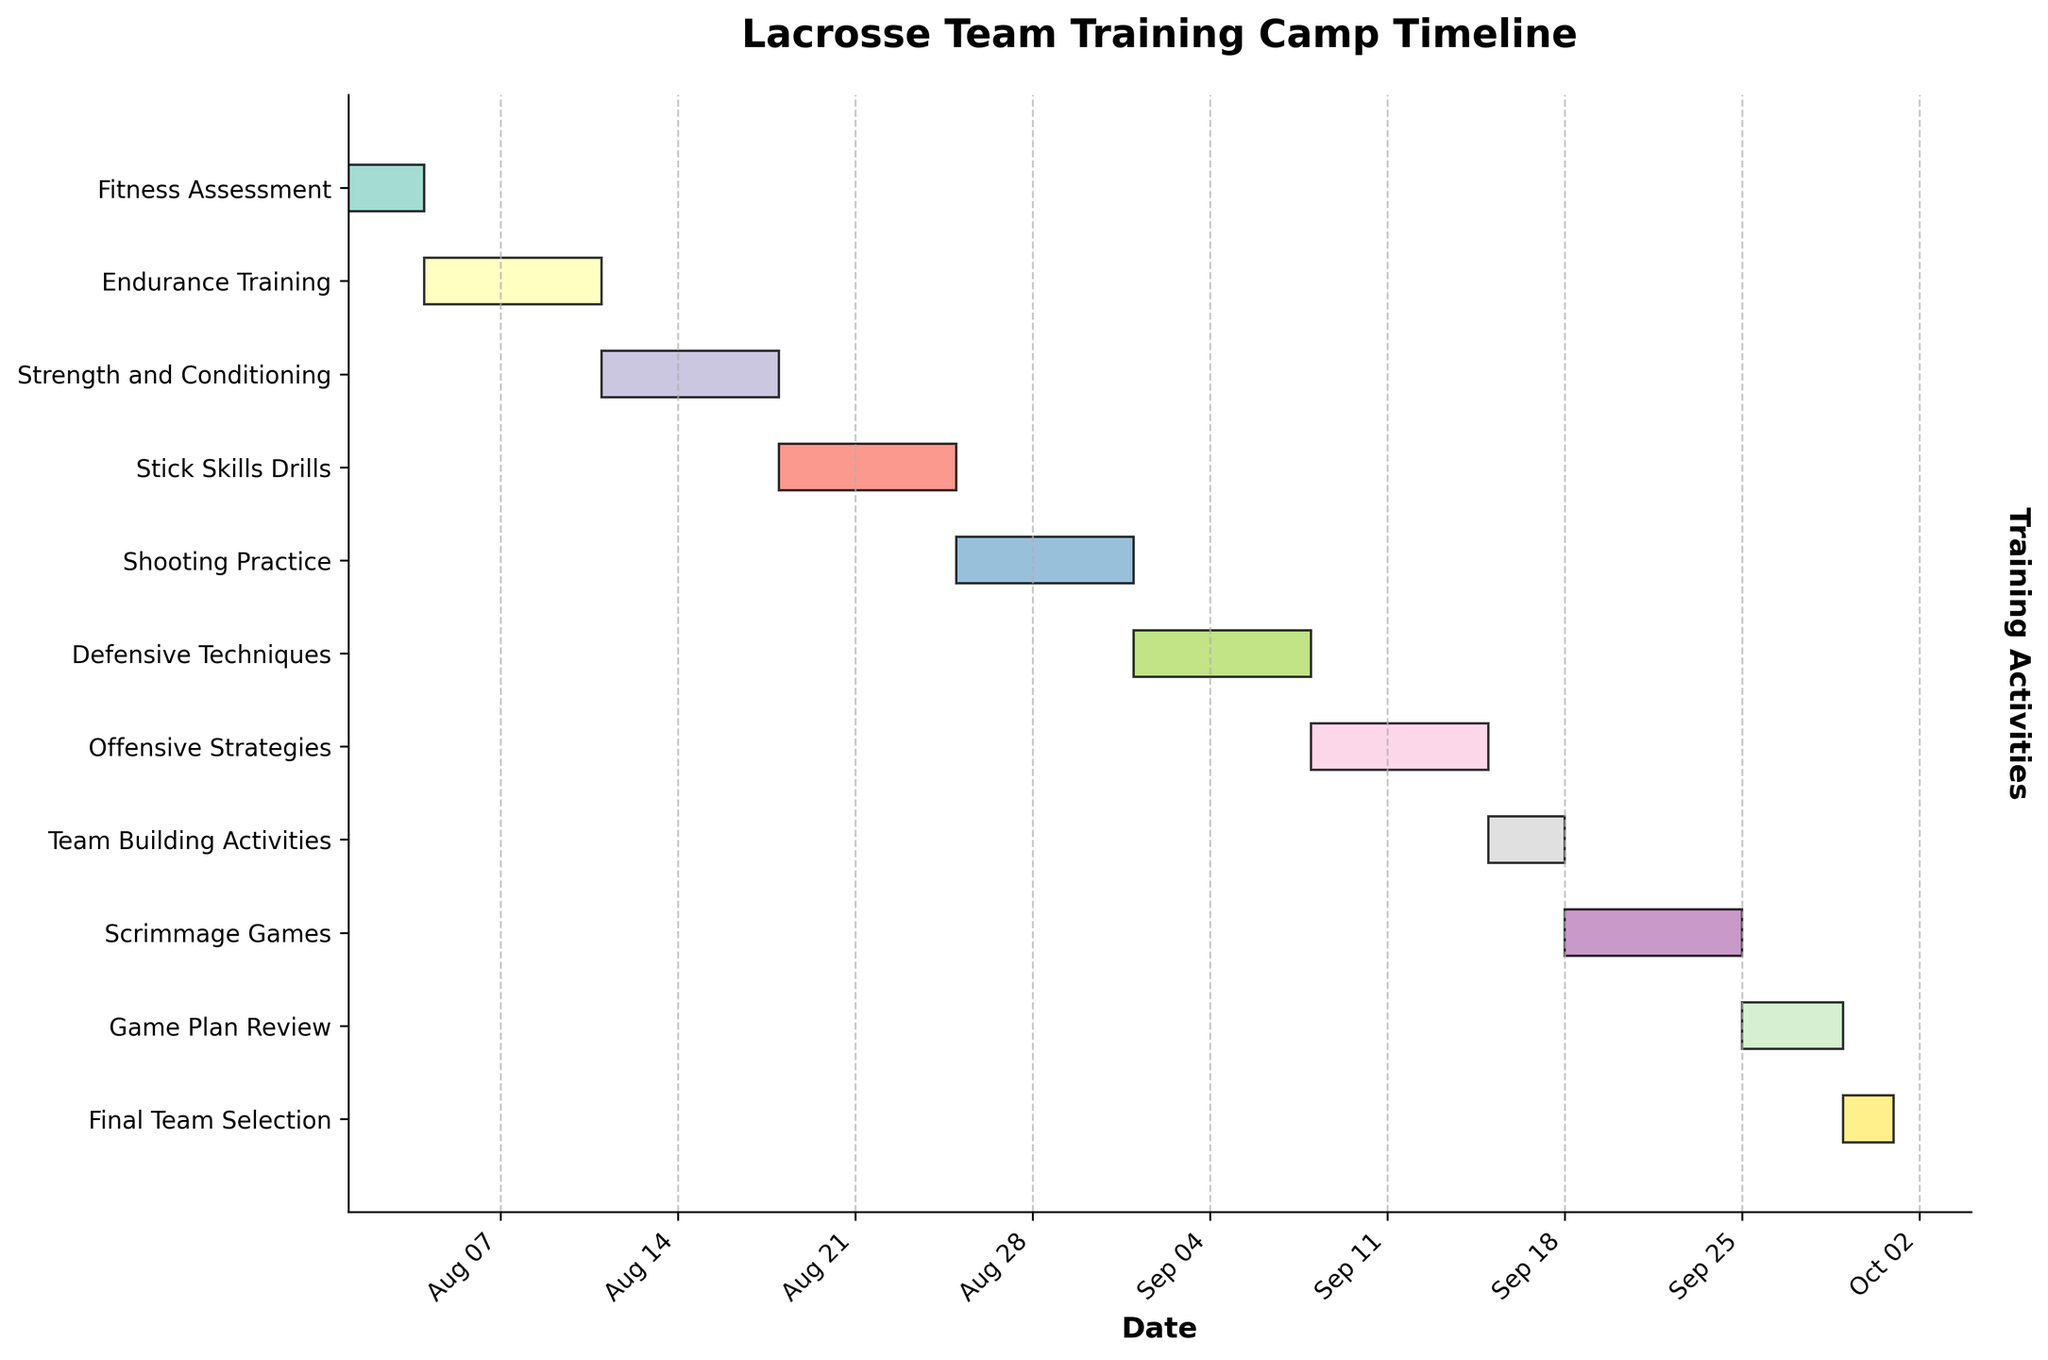What is the duration of the Fitness Assessment task? The Fitness Assessment task starts on August 1, 2023, and ends on August 3, 2023. The task duration is calculated as the difference between the start and end dates plus one day: (August 3 - August 1) + 1 = 3 days.
Answer: 3 days Which task has the longest duration and how long is it? By visually comparing the durations of all the tasks in the Gantt Chart, the Scrimmage Games task has the longest bar. The Scrimmage Games task starts on September 18, 2023, and ends on September 24, 2023. Therefore, its duration is (September 24 - September 18) + 1 = 7 days.
Answer: Scrimmage Games, 7 days What is the total duration of all training activities combined? Calculating the total duration involves summing up individual task durations: 3 (Fitness Assessment) + 7 (Endurance Training) + 7 (Strength and Conditioning) + 7 (Stick Skills Drills) + 7 (Shooting Practice) + 7 (Defensive Techniques) + 7 (Offensive Strategies) + 3 (Team Building Activities) + 7 (Scrimmage Games) + 4 (Game Plan Review) + 2 (Final Team Selection) = 61 days.
Answer: 61 days Which tasks overlap or happen sequentially without any gaps? Visually checking the timeline, the tasks Endurance Training, Strength and Conditioning, Stick Skills Drills, Shooting Practice, Defensive Techniques, and Offensive Strategies are sequential, each following the previous one without gaps. Additionally, the tasks Scrimmage Games and Game Plan Review are sequential.
Answer: Endurance Training to Offensive Strategies, Scrimmage Games to Game Plan Review How does the duration of Team Building Activities compare to Shooting Practice? The duration of Team Building Activities is 3 days, and the duration of Shooting Practice is 7 days. Therefore, Team Building Activities are shorter than Shooting Practice.
Answer: Team Building Activities are shorter What is the earliest starting task and the latest ending task? The earliest starting task is the Fitness Assessment, which begins on August 1, 2023. The latest ending task is the Final Team Selection, which ends on September 30, 2023.
Answer: Fitness Assessment, Final Team Selection Are there any tasks that start and end within the same month? If so, which ones? By examining the Gantt Chart, the following tasks start and end within the same month: Fitness Assessment (August), Endurance Training (August), Strength and Conditioning (August), Stick Skills Drills (August), Shooting Practice (August), Defensive Techniques (September), Offensive Strategies (September), Team Building Activities (September), Game Plan Review (September), and Final Team Selection (September).
Answer: Fitness Assessment, Endurance Training, Strength and Conditioning, Stick Skills Drills, Shooting Practice, Defensive Techniques, Offensive Strategies, Team Building Activities, Game Plan Review, Final Team Selection On which date does the Offensive Strategies session begin? The Offensive Strategies session begins on September 8, 2023, as indicated by its bar on the Gantt Chart.
Answer: September 8, 2023 What's the total duration of the skills training sessions? (Stick Skills Drills, Shooting Practice, Defensive Techniques, Offensive Strategies) Summing up the durations of the skills training sessions: Stick Skills Drills (7 days), Shooting Practice (7 days), Defensive Techniques (7 days), Offensive Strategies (7 days). Total duration: 7 + 7 + 7 + 7 = 28 days.
Answer: 28 days 